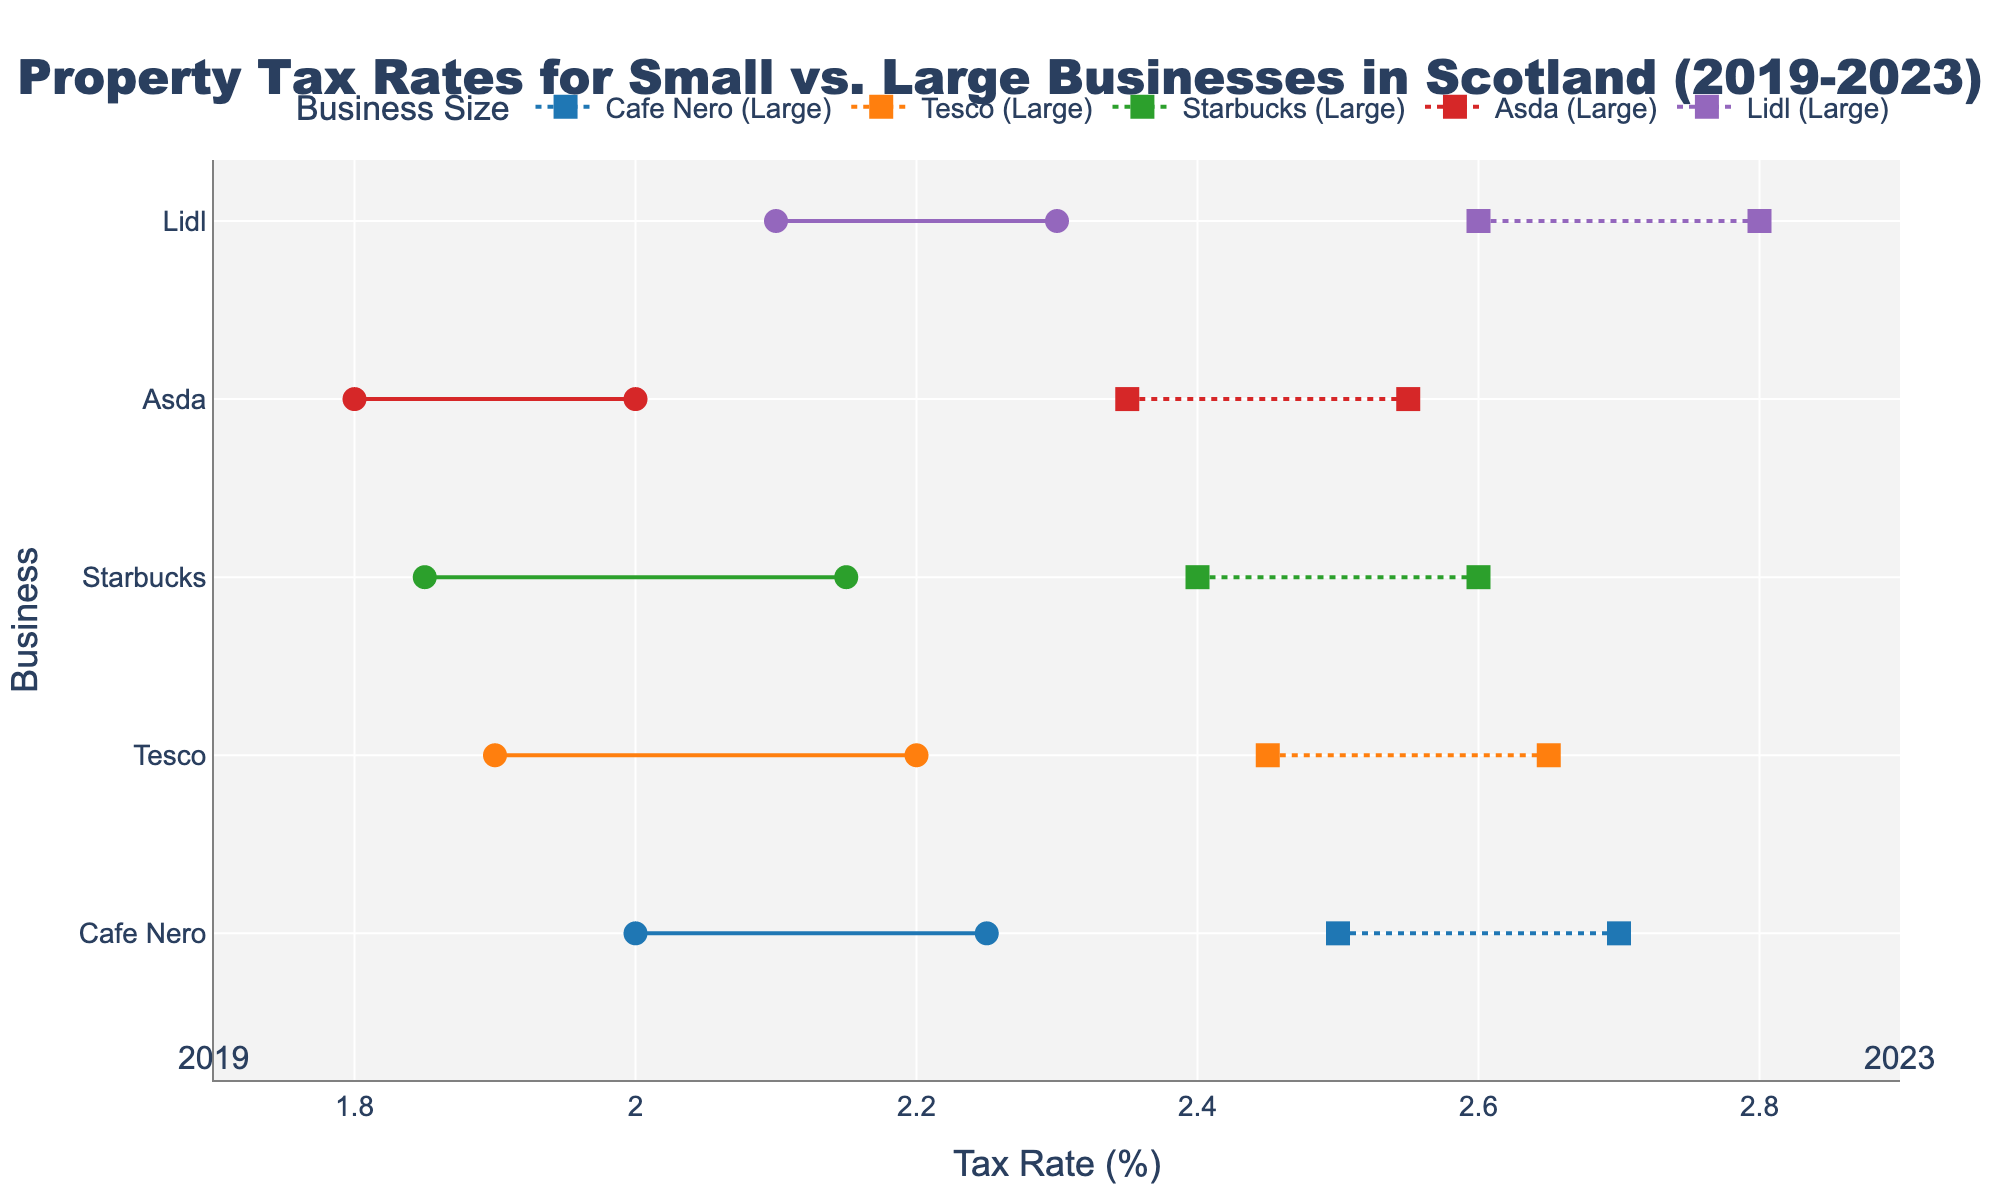What is the title of the plot? The title is located at the top center of the plot. It provides a summary of what the plot is about. The title is: "Property Tax Rates for Small vs. Large Businesses in Scotland (2019-2023)"
Answer: Property Tax Rates for Small vs. Large Businesses in Scotland (2019-2023) How many businesses are represented in the plot? We can count the number of unique business names listed on the y-axis. By doing so, we find that there are five businesses.
Answer: 5 Which business shows the highest tax rate difference between small and large sizes in 2023? For each business, identify the tax rate for small and large sizes in 2023 and calculate the difference. Lidl has the highest difference of 0.5% (2.8-2.3).
Answer: Lidl What is the change in tax rate for small businesses of Cafe Nero from 2019 to 2023? Find the tax rates for Cafe Nero (Small) in 2019 and 2023, then calculate the difference: 2.25 - 2.0 = 0.25.
Answer: 0.25 Which business had the smallest increase in tax rate for their large size from 2019 to 2023? For each business, identify the tax rate for large size in 2019 and 2023, then calculate the change. The smallest increase is for Asda, with an increase of 0.2% (2.55-2.35).
Answer: Asda Between 2019 and 2023, which business had the same increase in tax rate for both small and large sizes? Calculate the increase for both small and large sizes for each business. Tesco shows the same increase of 0.3% for both small (2.2-1.9) and large (2.65-2.45) sizes.
Answer: Tesco For which business is the tax rate for small size higher than that for large size in 2019? Compare the tax rates for small and large sizes for each business in 2019. None of the businesses have a higher tax rate for small size than large size in 2019.
Answer: None Which business shows a consistent pattern where the large size tax rate is always higher than the small size tax rate across all years? Compare the tax rates for small and large sizes for each business across all years. Each business consistently shows that the large size tax rate is higher than the small size tax rate across all years.
Answer: All businesses Which year had the least difference in tax rates for small and large sizes across all businesses? Calculate the difference in tax rates between small and large sizes for all businesses for each year, then find the year with the smallest average difference. 2023 has the smallest average difference.
Answer: 2023 